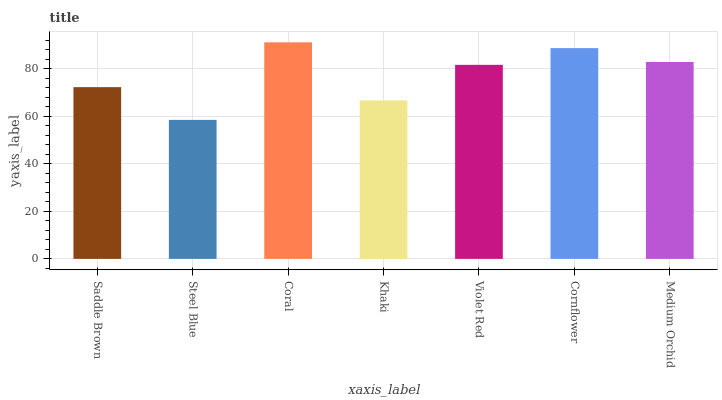Is Steel Blue the minimum?
Answer yes or no. Yes. Is Coral the maximum?
Answer yes or no. Yes. Is Coral the minimum?
Answer yes or no. No. Is Steel Blue the maximum?
Answer yes or no. No. Is Coral greater than Steel Blue?
Answer yes or no. Yes. Is Steel Blue less than Coral?
Answer yes or no. Yes. Is Steel Blue greater than Coral?
Answer yes or no. No. Is Coral less than Steel Blue?
Answer yes or no. No. Is Violet Red the high median?
Answer yes or no. Yes. Is Violet Red the low median?
Answer yes or no. Yes. Is Steel Blue the high median?
Answer yes or no. No. Is Coral the low median?
Answer yes or no. No. 